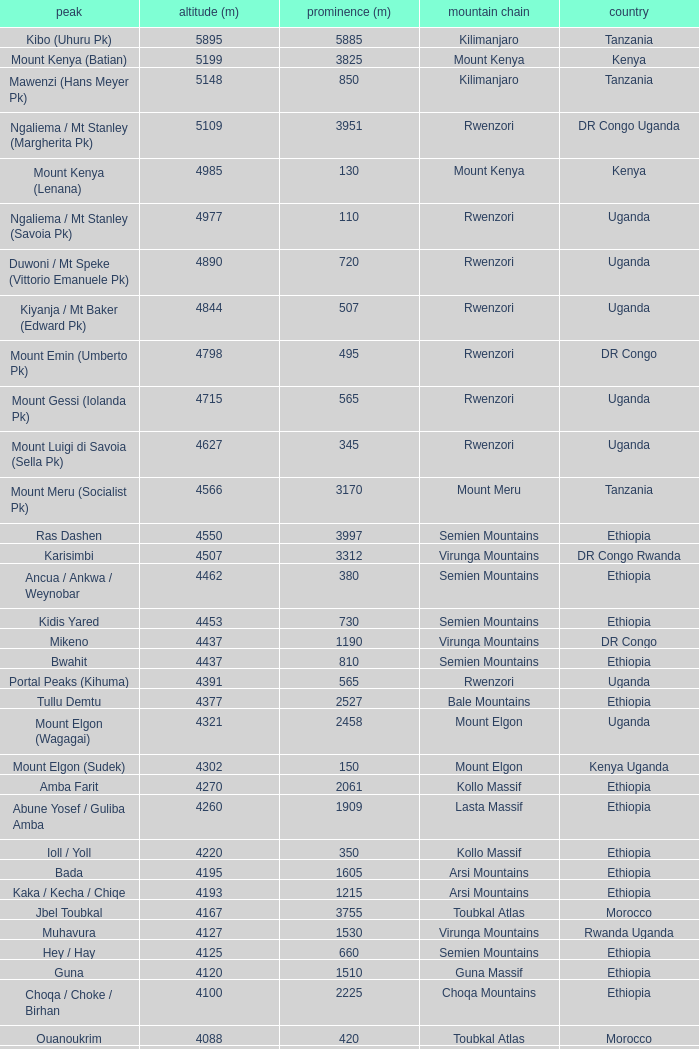How tall is the Mountain of jbel ghat? 1.0. 